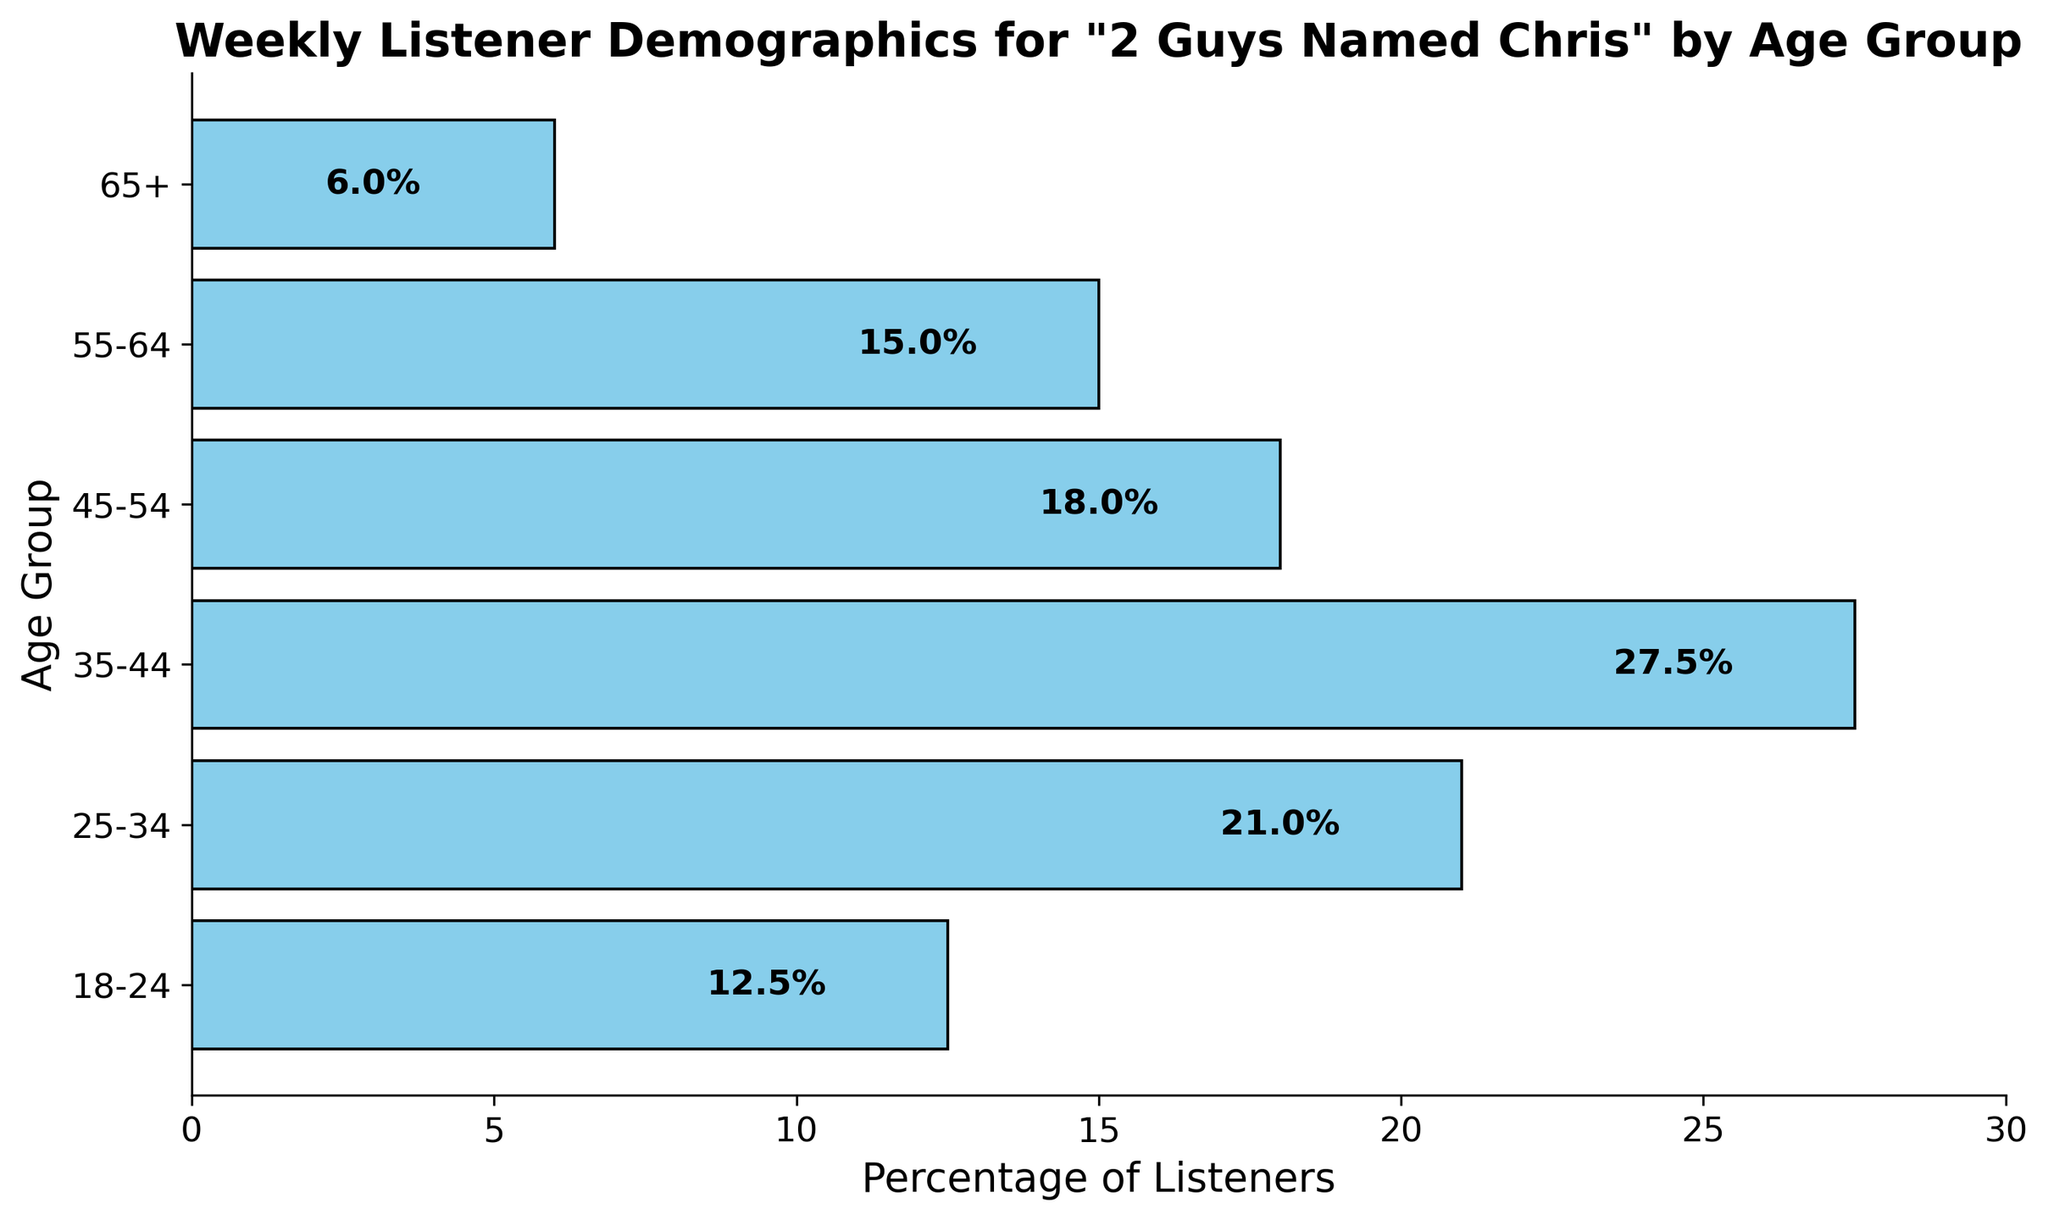What age group has the highest percentage of listeners? The bar for the 35-44 age group is the longest, indicating that 35-44 has the highest percentage.
Answer: 35-44 Which two age groups together make up more than half of the listeners? The 35-44 group makes up 27.5%, and the 25-34 group makes up 21.0%. Summing these gives 27.5% + 21.0% = 48.5%, which is less than half. Adding the next highest age group, 45-54 with 18.0%, results in 27.5% + 21.0% + 18.0% = 66.5%, which is more than half.
Answer: 35-44 and 25-34 What is the combined percentage of listeners aged 55 and above? Adding the percentages of the 55-64 group and the 65+ group gives 15.0% + 6.0% = 21.0%.
Answer: 21.0% How does the percentage of listeners aged 18-24 compare to those aged 65+? The 18-24 group has 12.5% and the 65+ group has 6.0%. Therefore, 18-24 has a higher percentage by 12.5% - 6.0% = 6.5%.
Answer: 18-24 has 6.5% more Which age group has the smallest percentage of listeners? The bar for the 65+ group is the shortest, indicating it has the smallest percentage of listeners.
Answer: 65+ How much larger is the percentage of listeners aged 35-44 compared to those aged 18-24? The 35-44 group has 27.5%, and the 18-24 group has 12.5%. The difference is 27.5% - 12.5% = 15.0%.
Answer: 15.0% What is the percentage difference between the age groups 25-34 and 45-54? The 25-34 group has 21.0%, and the 45-54 group has 18.0%. The difference is 21.0% - 18.0% = 3.0%.
Answer: 3.0% If the three middle age groups are combined, what is their total percentage of listeners? Combining the 25-34 (21.0%), 35-44 (27.5%), and 45-54 (18.0%) groups gives 21.0% + 27.5% + 18.0% = 66.5%.
Answer: 66.5% Which age group has a percentage closest to the average percentage across all groups? The average percentage is (12.5% + 21.0% + 27.5% + 18.0% + 15.0% + 6.0%) / 6 = 100.0% / 6 ≈ 16.7%. The 55-64 group has a percentage of 15.0%, which is closest to 16.7%.
Answer: 55-64 